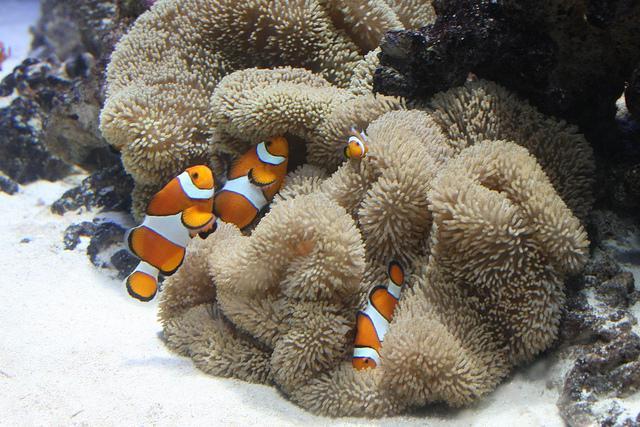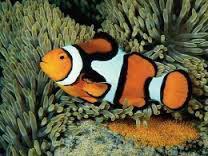The first image is the image on the left, the second image is the image on the right. For the images shown, is this caption "There are 5 clownfish swimming." true? Answer yes or no. Yes. 